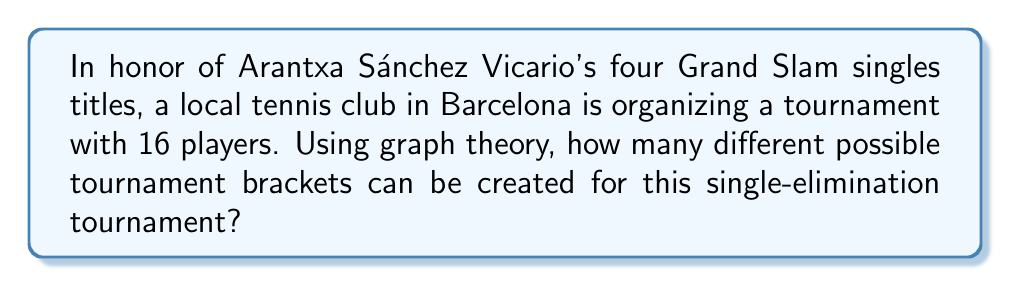Can you answer this question? To solve this problem, we can use the concept of labeled trees in graph theory. Here's a step-by-step explanation:

1) In a single-elimination tournament with 16 players, there will be 15 matches in total (one less than the number of players).

2) The tournament bracket can be represented as a binary tree with 16 leaf nodes (representing the players) and 15 internal nodes (representing the matches).

3) According to Cayley's formula, the number of labeled trees with $n$ vertices is $n^{n-2}$.

4) In our case, we're interested in the number of labeled binary trees with 15 internal nodes (the matches). The leaf nodes (players) are fixed and don't contribute to the counting.

5) Therefore, we can apply Cayley's formula with $n = 15$:

   Number of possible brackets = $15^{15-2} = 15^{13}$

6) To calculate this:
   $$15^{13} = 2,375,880,867,361,328,125$$

This enormous number represents all possible ways to arrange the matches in the tournament bracket, each potentially leading to a different tournament outcome.
Answer: $15^{13} = 2,375,880,867,361,328,125$ possible tournament brackets 